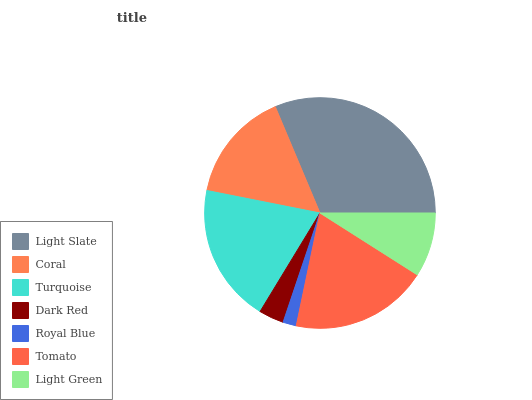Is Royal Blue the minimum?
Answer yes or no. Yes. Is Light Slate the maximum?
Answer yes or no. Yes. Is Coral the minimum?
Answer yes or no. No. Is Coral the maximum?
Answer yes or no. No. Is Light Slate greater than Coral?
Answer yes or no. Yes. Is Coral less than Light Slate?
Answer yes or no. Yes. Is Coral greater than Light Slate?
Answer yes or no. No. Is Light Slate less than Coral?
Answer yes or no. No. Is Coral the high median?
Answer yes or no. Yes. Is Coral the low median?
Answer yes or no. Yes. Is Light Green the high median?
Answer yes or no. No. Is Turquoise the low median?
Answer yes or no. No. 